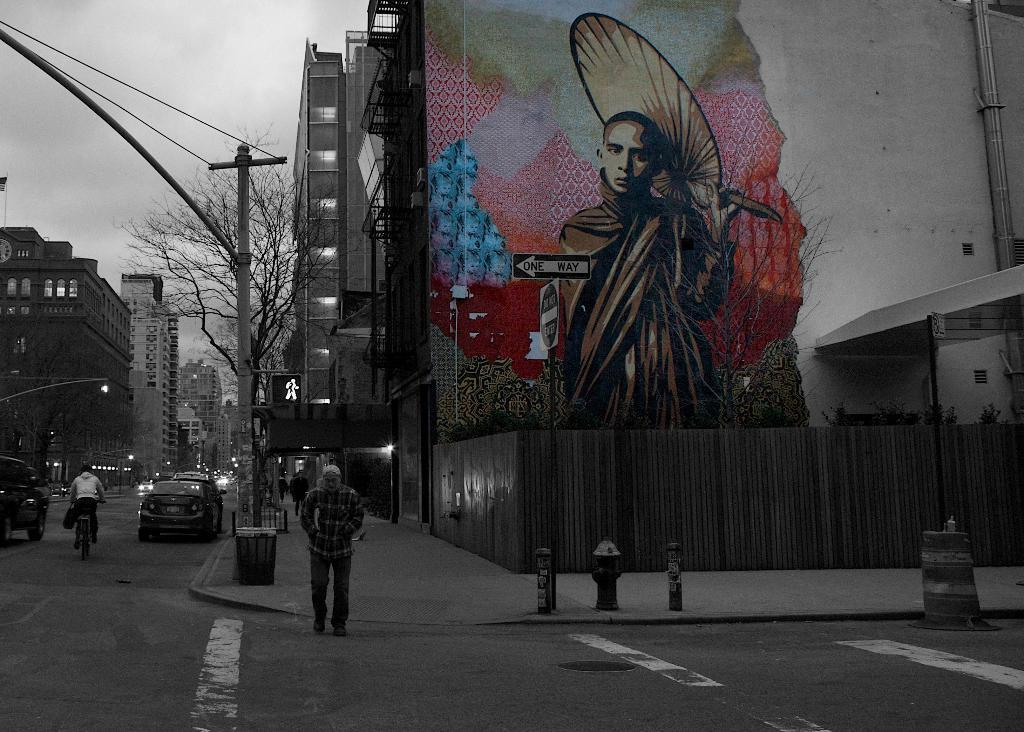What type of structures can be seen in the image? There are buildings in the image. What natural elements are present in the image? There are trees in the image. What type of utility infrastructure is visible in the image? There is a current pole in the image. Are there any living beings visible in the image? Yes, there are people visible in the image. What type of transportation can be seen in the image? There are cars and a bicycle in the image. Where is the hen located in the image? There is no hen present in the image. What type of key is used to unlock the bicycle in the image? There is no key involved in the image, as the bicycle does not require a key to operate. 